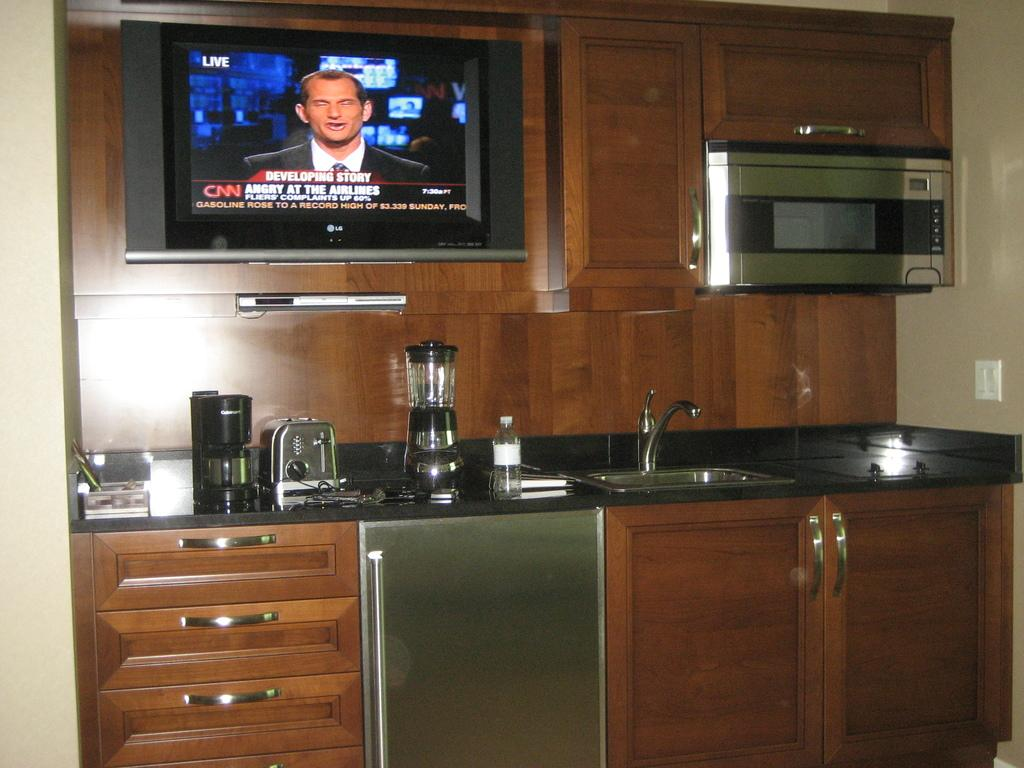<image>
Offer a succinct explanation of the picture presented. A modern counter top with a TV displaying live footage from CNN. 